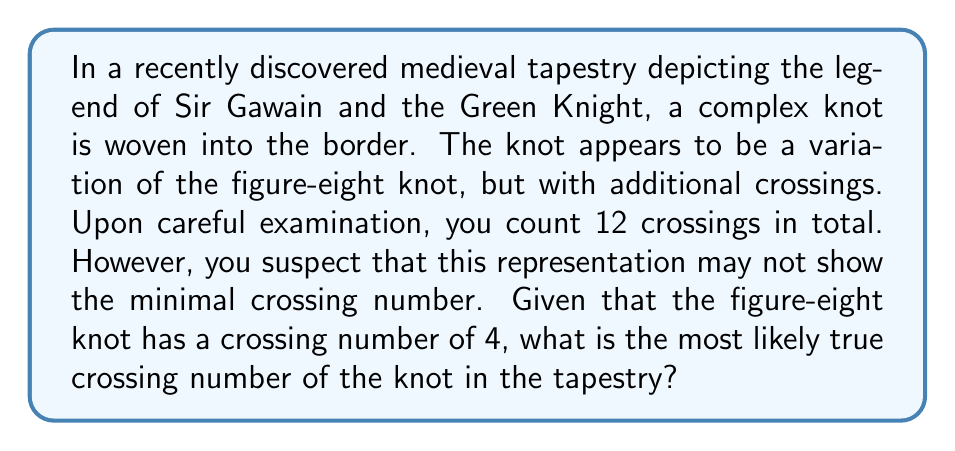Can you answer this question? To determine the most likely true crossing number of the knot in the tapestry, we need to consider the following steps:

1. Recall that the figure-eight knot has a crossing number of 4.

2. The tapestry shows 12 crossings, which is significantly more than the figure-eight knot's minimal crossing number.

3. In medieval art, knots were often depicted with more crossings than necessary for aesthetic purposes or due to limitations in accurately representing three-dimensional structures in two-dimensional art.

4. The next prime knot after the figure-eight knot (4₁) in the knot table is the cinquefoil knot (5₁), which has a crossing number of 5.

5. Given that the knot is described as a "variation" of the figure-eight knot, it's unlikely to be a much more complex prime knot.

6. The most probable explanation is that the additional crossings in the tapestry are extraneous and can be removed through Reidemeister moves without changing the knot type.

7. Therefore, the most likely true crossing number would be either 4 (if it's actually a figure-eight knot) or 5 (if it's a slight variation that adds one essential crossing).

8. Since the question asks for the "most likely" crossing number, and we're told it's a "variation" of the figure-eight knot, we should lean towards the next available crossing number.

Thus, the most likely true crossing number of the knot depicted in the tapestry is 5.
Answer: 5 